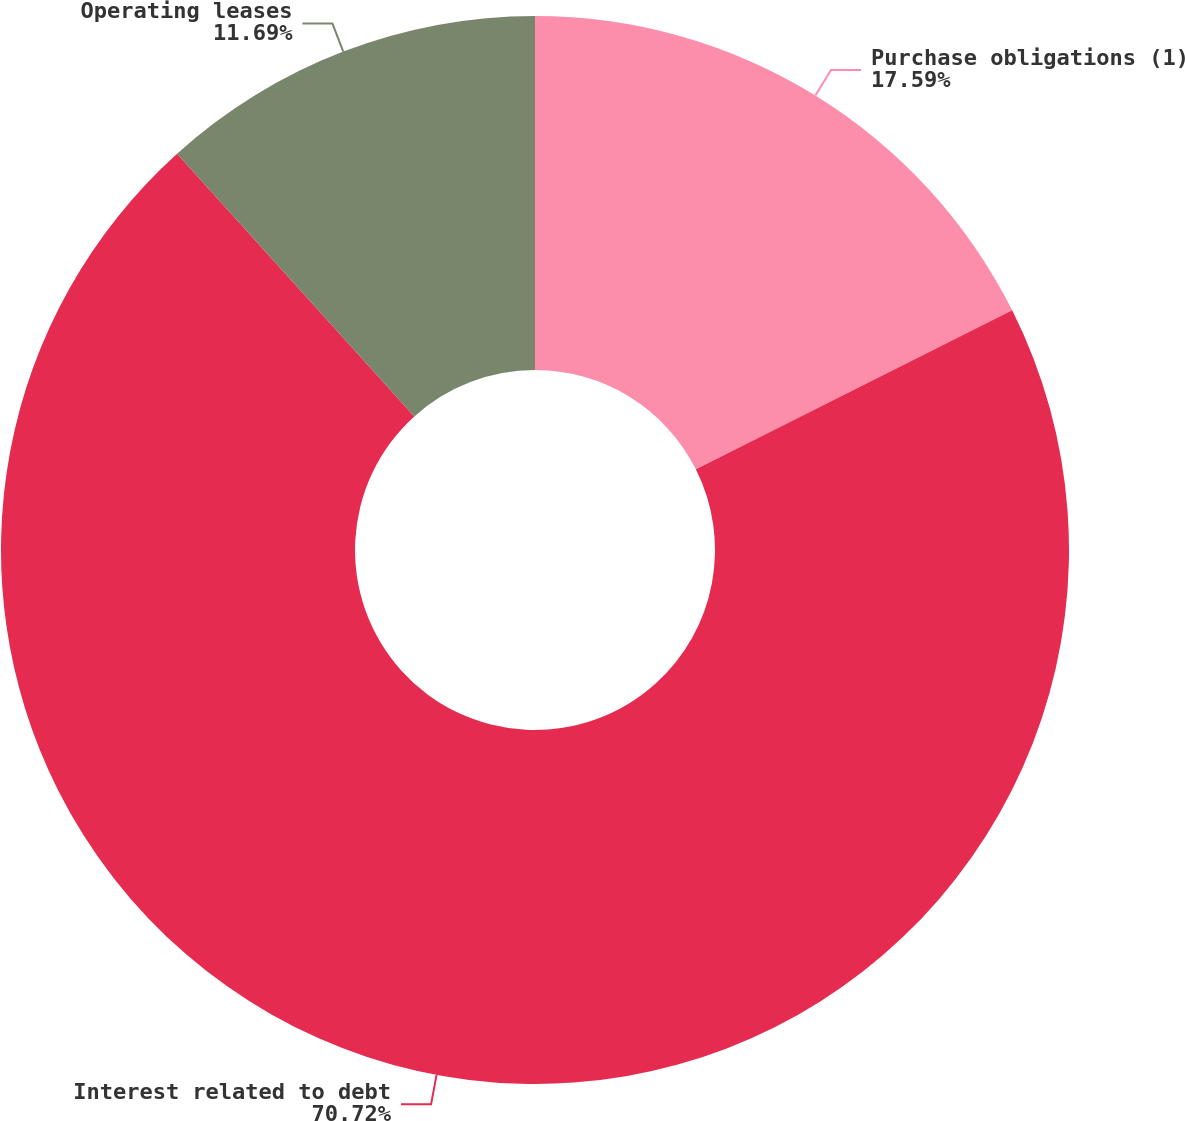<chart> <loc_0><loc_0><loc_500><loc_500><pie_chart><fcel>Purchase obligations (1)<fcel>Interest related to debt<fcel>Operating leases<nl><fcel>17.59%<fcel>70.71%<fcel>11.69%<nl></chart> 